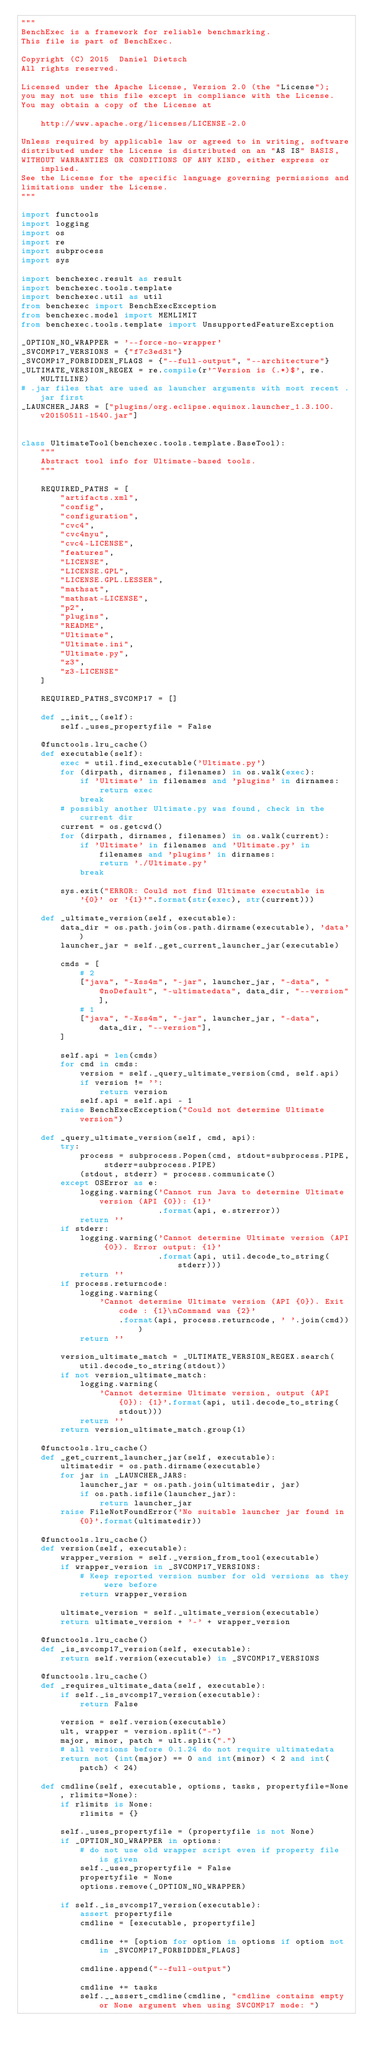<code> <loc_0><loc_0><loc_500><loc_500><_Python_>"""
BenchExec is a framework for reliable benchmarking.
This file is part of BenchExec.

Copyright (C) 2015  Daniel Dietsch
All rights reserved.

Licensed under the Apache License, Version 2.0 (the "License");
you may not use this file except in compliance with the License.
You may obtain a copy of the License at

    http://www.apache.org/licenses/LICENSE-2.0

Unless required by applicable law or agreed to in writing, software
distributed under the License is distributed on an "AS IS" BASIS,
WITHOUT WARRANTIES OR CONDITIONS OF ANY KIND, either express or implied.
See the License for the specific language governing permissions and
limitations under the License.
"""

import functools
import logging
import os
import re
import subprocess
import sys

import benchexec.result as result
import benchexec.tools.template
import benchexec.util as util
from benchexec import BenchExecException
from benchexec.model import MEMLIMIT
from benchexec.tools.template import UnsupportedFeatureException

_OPTION_NO_WRAPPER = '--force-no-wrapper'
_SVCOMP17_VERSIONS = {"f7c3ed31"}
_SVCOMP17_FORBIDDEN_FLAGS = {"--full-output", "--architecture"}
_ULTIMATE_VERSION_REGEX = re.compile(r'^Version is (.*)$', re.MULTILINE)
# .jar files that are used as launcher arguments with most recent .jar first
_LAUNCHER_JARS = ["plugins/org.eclipse.equinox.launcher_1.3.100.v20150511-1540.jar"]


class UltimateTool(benchexec.tools.template.BaseTool):
    """
    Abstract tool info for Ultimate-based tools.
    """

    REQUIRED_PATHS = [
        "artifacts.xml",
        "config",
        "configuration",
        "cvc4",
        "cvc4nyu",
        "cvc4-LICENSE",
        "features",
        "LICENSE",
        "LICENSE.GPL",
        "LICENSE.GPL.LESSER",
        "mathsat",
        "mathsat-LICENSE",
        "p2",
        "plugins",
        "README",
        "Ultimate",
        "Ultimate.ini",
        "Ultimate.py",
        "z3",
        "z3-LICENSE"
    ]

    REQUIRED_PATHS_SVCOMP17 = []

    def __init__(self):
        self._uses_propertyfile = False

    @functools.lru_cache()
    def executable(self):
        exec = util.find_executable('Ultimate.py')
        for (dirpath, dirnames, filenames) in os.walk(exec):
            if 'Ultimate' in filenames and 'plugins' in dirnames:
                return exec
            break
        # possibly another Ultimate.py was found, check in the current dir
        current = os.getcwd()
        for (dirpath, dirnames, filenames) in os.walk(current):
            if 'Ultimate' in filenames and 'Ultimate.py' in filenames and 'plugins' in dirnames:
                return './Ultimate.py'
            break

        sys.exit("ERROR: Could not find Ultimate executable in '{0}' or '{1}'".format(str(exec), str(current)))

    def _ultimate_version(self, executable):
        data_dir = os.path.join(os.path.dirname(executable), 'data')
        launcher_jar = self._get_current_launcher_jar(executable)

        cmds = [
            # 2
            ["java", "-Xss4m", "-jar", launcher_jar, "-data", "@noDefault", "-ultimatedata", data_dir, "--version"],
            # 1
            ["java", "-Xss4m", "-jar", launcher_jar, "-data", data_dir, "--version"],
        ]

        self.api = len(cmds)
        for cmd in cmds:
            version = self._query_ultimate_version(cmd, self.api)
            if version != '':
                return version
            self.api = self.api - 1
        raise BenchExecException("Could not determine Ultimate version")

    def _query_ultimate_version(self, cmd, api):
        try:
            process = subprocess.Popen(cmd, stdout=subprocess.PIPE, stderr=subprocess.PIPE)
            (stdout, stderr) = process.communicate()
        except OSError as e:
            logging.warning('Cannot run Java to determine Ultimate version (API {0}): {1}'
                            .format(api, e.strerror))
            return ''
        if stderr:
            logging.warning('Cannot determine Ultimate version (API {0}). Error output: {1}'
                            .format(api, util.decode_to_string(stderr)))
            return ''
        if process.returncode:
            logging.warning(
                'Cannot determine Ultimate version (API {0}). Exit code : {1}\nCommand was {2}'
                    .format(api, process.returncode, ' '.join(cmd)))
            return ''

        version_ultimate_match = _ULTIMATE_VERSION_REGEX.search(util.decode_to_string(stdout))
        if not version_ultimate_match:
            logging.warning(
                'Cannot determine Ultimate version, output (API {0}): {1}'.format(api, util.decode_to_string(stdout)))
            return ''
        return version_ultimate_match.group(1)

    @functools.lru_cache()
    def _get_current_launcher_jar(self, executable):
        ultimatedir = os.path.dirname(executable)
        for jar in _LAUNCHER_JARS:
            launcher_jar = os.path.join(ultimatedir, jar)
            if os.path.isfile(launcher_jar):
                return launcher_jar
        raise FileNotFoundError('No suitable launcher jar found in {0}'.format(ultimatedir))

    @functools.lru_cache()
    def version(self, executable):
        wrapper_version = self._version_from_tool(executable)
        if wrapper_version in _SVCOMP17_VERSIONS:
            # Keep reported version number for old versions as they were before
            return wrapper_version

        ultimate_version = self._ultimate_version(executable)
        return ultimate_version + '-' + wrapper_version

    @functools.lru_cache()
    def _is_svcomp17_version(self, executable):
        return self.version(executable) in _SVCOMP17_VERSIONS

    @functools.lru_cache()
    def _requires_ultimate_data(self, executable):
        if self._is_svcomp17_version(executable):
            return False

        version = self.version(executable)
        ult, wrapper = version.split("-")
        major, minor, patch = ult.split(".")
        # all versions before 0.1.24 do not require ultimatedata
        return not (int(major) == 0 and int(minor) < 2 and int(patch) < 24)

    def cmdline(self, executable, options, tasks, propertyfile=None, rlimits=None):
        if rlimits is None:
            rlimits = {}

        self._uses_propertyfile = (propertyfile is not None)
        if _OPTION_NO_WRAPPER in options:
            # do not use old wrapper script even if property file is given
            self._uses_propertyfile = False
            propertyfile = None
            options.remove(_OPTION_NO_WRAPPER)

        if self._is_svcomp17_version(executable):
            assert propertyfile
            cmdline = [executable, propertyfile]

            cmdline += [option for option in options if option not in _SVCOMP17_FORBIDDEN_FLAGS]

            cmdline.append("--full-output")

            cmdline += tasks
            self.__assert_cmdline(cmdline, "cmdline contains empty or None argument when using SVCOMP17 mode: ")</code> 